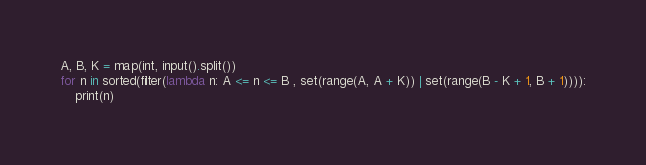<code> <loc_0><loc_0><loc_500><loc_500><_Python_>A, B, K = map(int, input().split())
for n in sorted(filter(lambda n: A <= n <= B , set(range(A, A + K)) | set(range(B - K + 1, B + 1)))):
    print(n)
</code> 